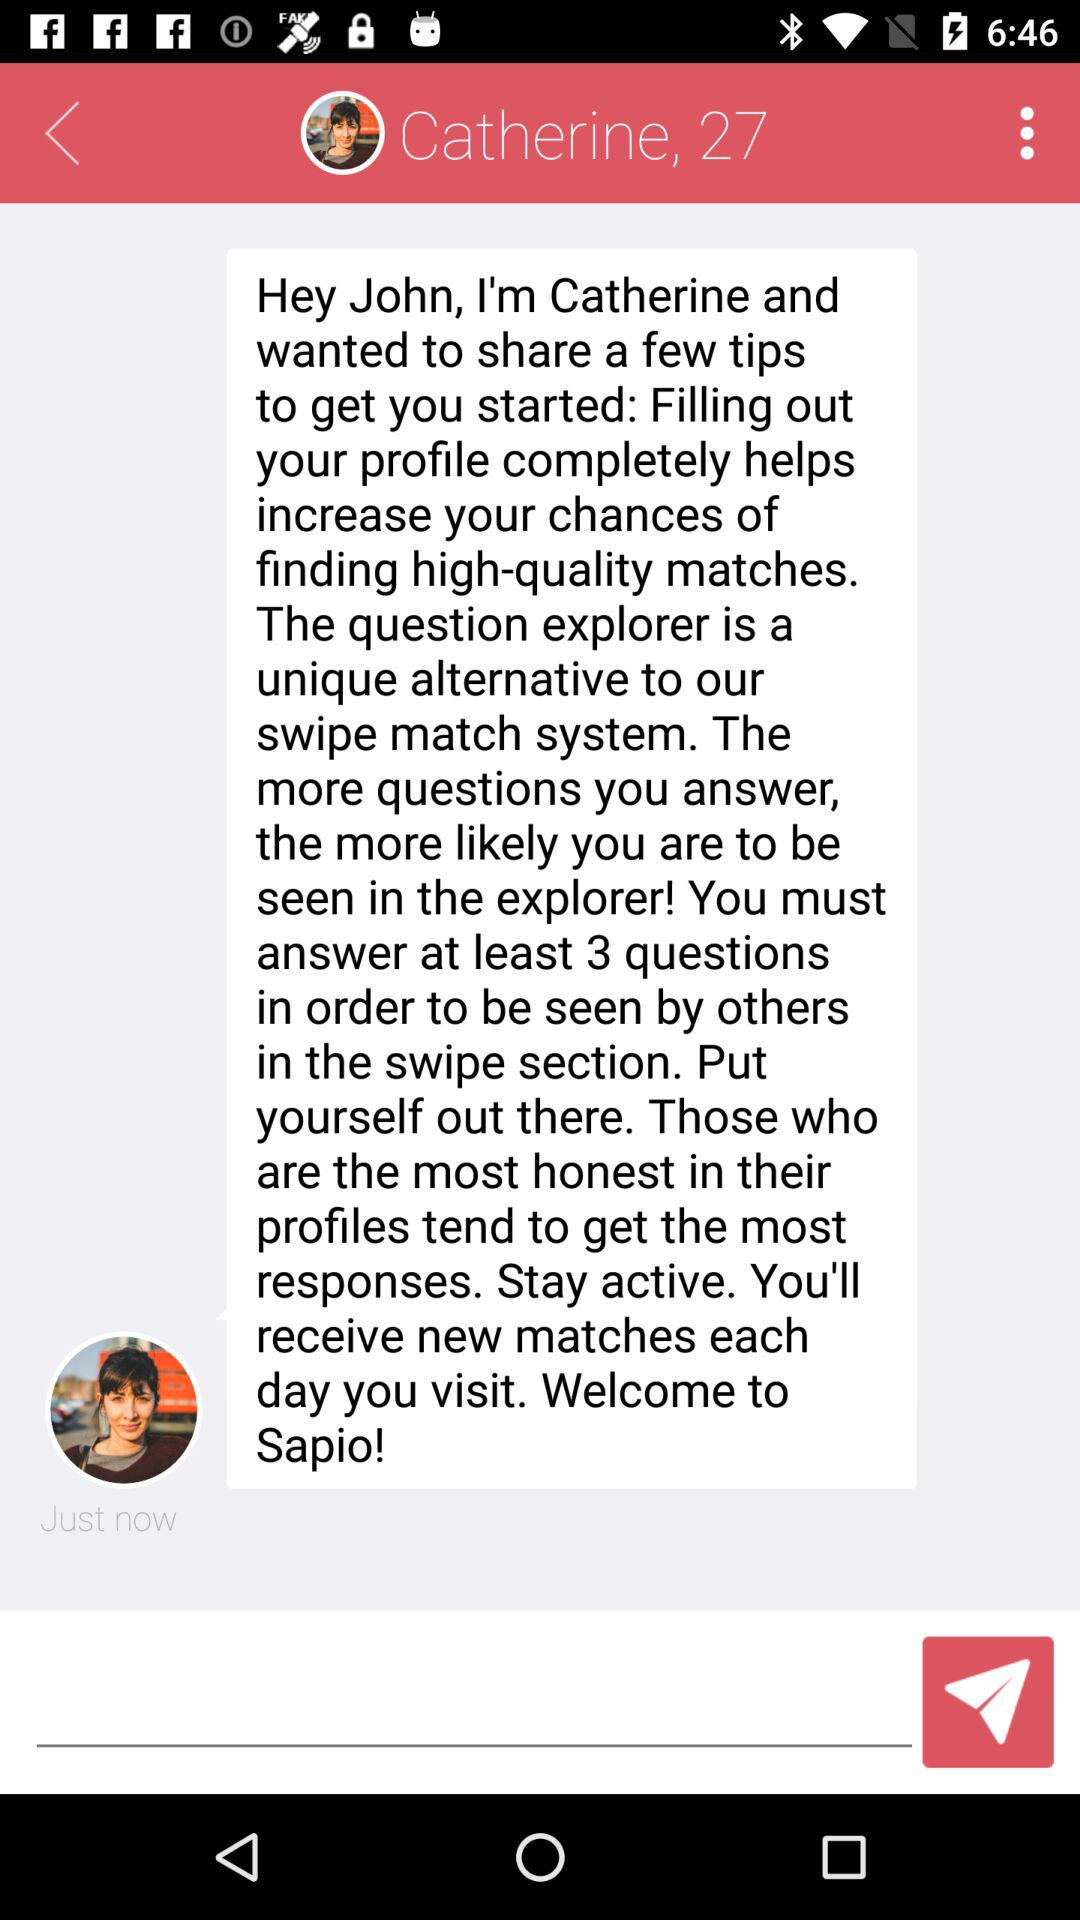What is the age of the person? The age of the person is 27. 